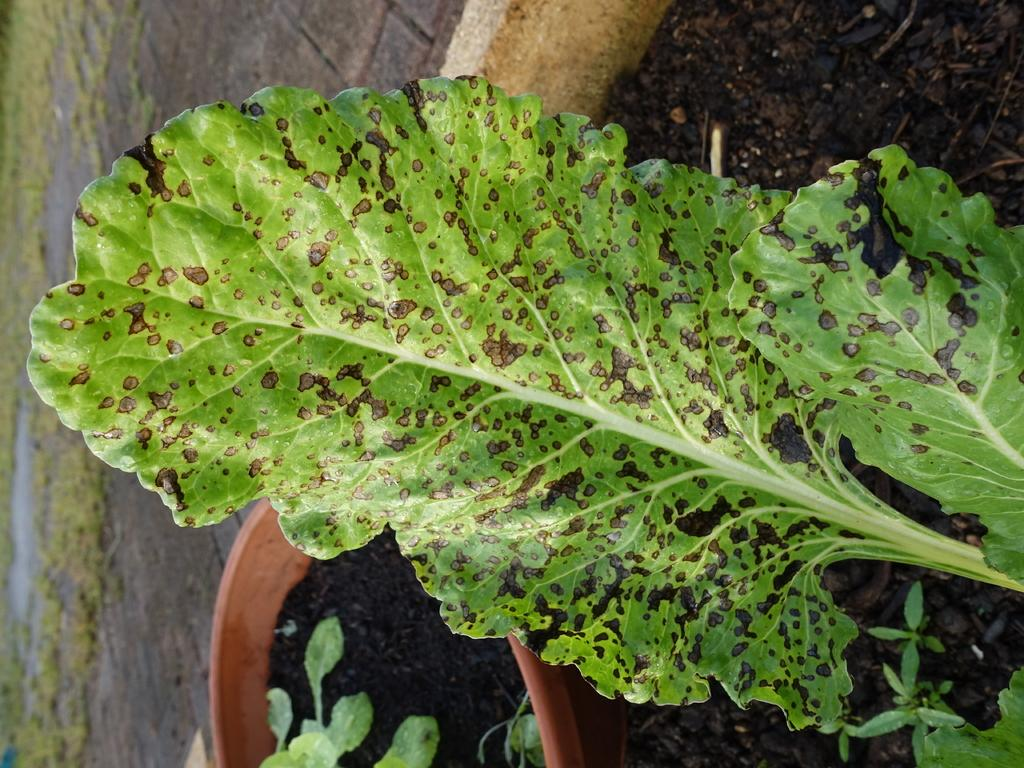What is present in the image that is related to plants? There is a leaf in the image, and there are other plants in a pot. Can you describe the leaf in the image? The leaf has black spots. What type of cloth is being used to represent the leaf in the image? There is no cloth present in the image, and the leaf is not a representation; it is a real leaf. 